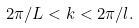<formula> <loc_0><loc_0><loc_500><loc_500>2 \pi / L < k < 2 \pi / l .</formula> 